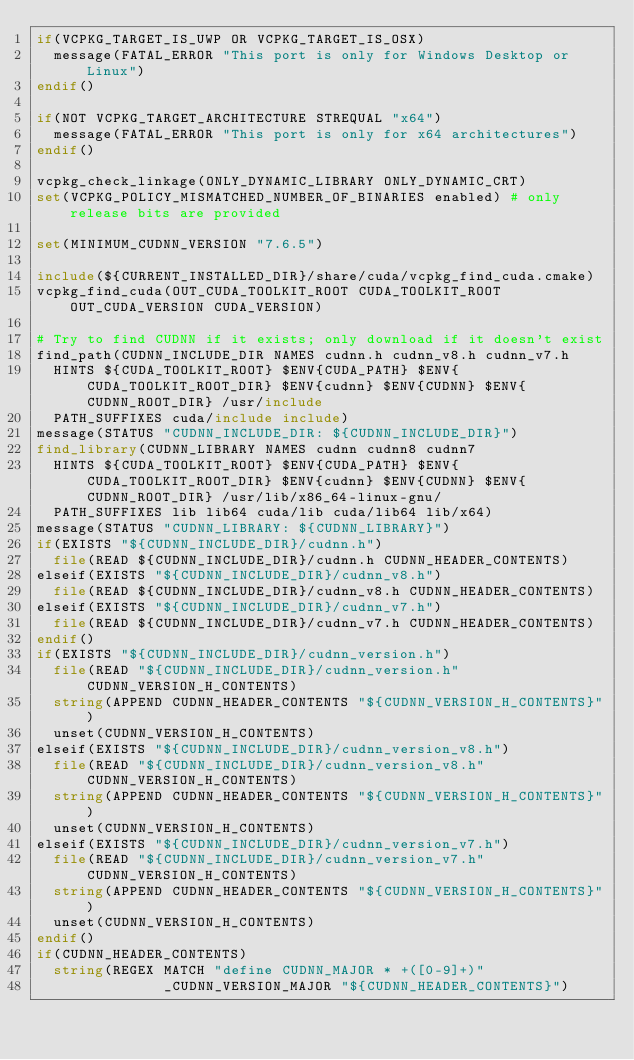<code> <loc_0><loc_0><loc_500><loc_500><_CMake_>if(VCPKG_TARGET_IS_UWP OR VCPKG_TARGET_IS_OSX)
  message(FATAL_ERROR "This port is only for Windows Desktop or Linux")
endif()

if(NOT VCPKG_TARGET_ARCHITECTURE STREQUAL "x64")
  message(FATAL_ERROR "This port is only for x64 architectures")
endif()

vcpkg_check_linkage(ONLY_DYNAMIC_LIBRARY ONLY_DYNAMIC_CRT)
set(VCPKG_POLICY_MISMATCHED_NUMBER_OF_BINARIES enabled) # only release bits are provided

set(MINIMUM_CUDNN_VERSION "7.6.5")

include(${CURRENT_INSTALLED_DIR}/share/cuda/vcpkg_find_cuda.cmake)
vcpkg_find_cuda(OUT_CUDA_TOOLKIT_ROOT CUDA_TOOLKIT_ROOT OUT_CUDA_VERSION CUDA_VERSION)

# Try to find CUDNN if it exists; only download if it doesn't exist
find_path(CUDNN_INCLUDE_DIR NAMES cudnn.h cudnn_v8.h cudnn_v7.h
  HINTS ${CUDA_TOOLKIT_ROOT} $ENV{CUDA_PATH} $ENV{CUDA_TOOLKIT_ROOT_DIR} $ENV{cudnn} $ENV{CUDNN} $ENV{CUDNN_ROOT_DIR} /usr/include
  PATH_SUFFIXES cuda/include include)
message(STATUS "CUDNN_INCLUDE_DIR: ${CUDNN_INCLUDE_DIR}")
find_library(CUDNN_LIBRARY NAMES cudnn cudnn8 cudnn7
  HINTS ${CUDA_TOOLKIT_ROOT} $ENV{CUDA_PATH} $ENV{CUDA_TOOLKIT_ROOT_DIR} $ENV{cudnn} $ENV{CUDNN} $ENV{CUDNN_ROOT_DIR} /usr/lib/x86_64-linux-gnu/
  PATH_SUFFIXES lib lib64 cuda/lib cuda/lib64 lib/x64)
message(STATUS "CUDNN_LIBRARY: ${CUDNN_LIBRARY}")
if(EXISTS "${CUDNN_INCLUDE_DIR}/cudnn.h")
  file(READ ${CUDNN_INCLUDE_DIR}/cudnn.h CUDNN_HEADER_CONTENTS)
elseif(EXISTS "${CUDNN_INCLUDE_DIR}/cudnn_v8.h")
  file(READ ${CUDNN_INCLUDE_DIR}/cudnn_v8.h CUDNN_HEADER_CONTENTS)
elseif(EXISTS "${CUDNN_INCLUDE_DIR}/cudnn_v7.h")
  file(READ ${CUDNN_INCLUDE_DIR}/cudnn_v7.h CUDNN_HEADER_CONTENTS)
endif()
if(EXISTS "${CUDNN_INCLUDE_DIR}/cudnn_version.h")
  file(READ "${CUDNN_INCLUDE_DIR}/cudnn_version.h" CUDNN_VERSION_H_CONTENTS)
  string(APPEND CUDNN_HEADER_CONTENTS "${CUDNN_VERSION_H_CONTENTS}")
  unset(CUDNN_VERSION_H_CONTENTS)
elseif(EXISTS "${CUDNN_INCLUDE_DIR}/cudnn_version_v8.h")
  file(READ "${CUDNN_INCLUDE_DIR}/cudnn_version_v8.h" CUDNN_VERSION_H_CONTENTS)
  string(APPEND CUDNN_HEADER_CONTENTS "${CUDNN_VERSION_H_CONTENTS}")
  unset(CUDNN_VERSION_H_CONTENTS)
elseif(EXISTS "${CUDNN_INCLUDE_DIR}/cudnn_version_v7.h")
  file(READ "${CUDNN_INCLUDE_DIR}/cudnn_version_v7.h" CUDNN_VERSION_H_CONTENTS)
  string(APPEND CUDNN_HEADER_CONTENTS "${CUDNN_VERSION_H_CONTENTS}")
  unset(CUDNN_VERSION_H_CONTENTS)
endif()
if(CUDNN_HEADER_CONTENTS)
  string(REGEX MATCH "define CUDNN_MAJOR * +([0-9]+)"
               _CUDNN_VERSION_MAJOR "${CUDNN_HEADER_CONTENTS}")</code> 